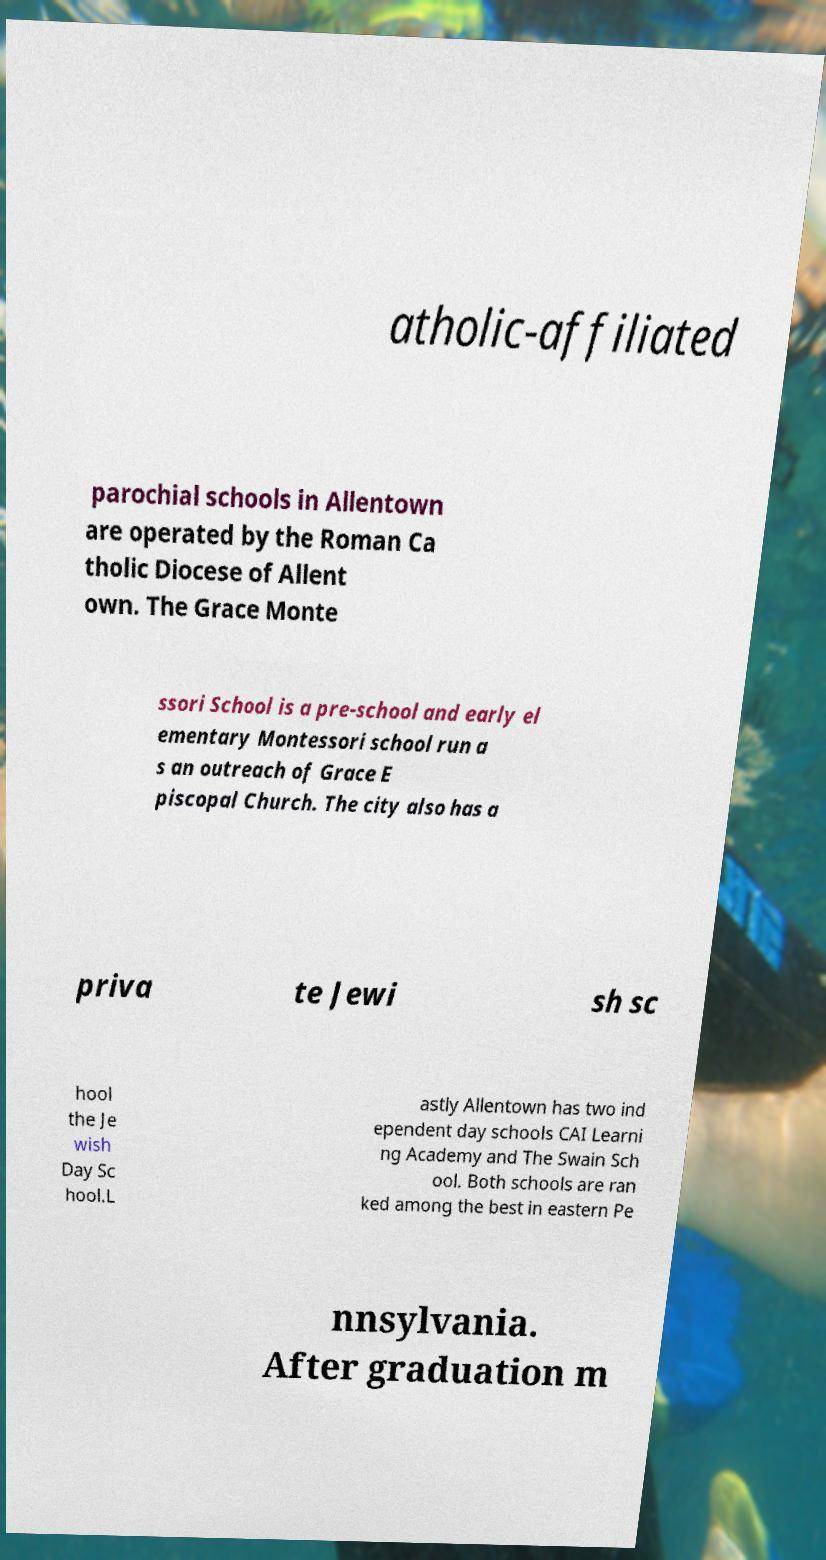Please identify and transcribe the text found in this image. atholic-affiliated parochial schools in Allentown are operated by the Roman Ca tholic Diocese of Allent own. The Grace Monte ssori School is a pre-school and early el ementary Montessori school run a s an outreach of Grace E piscopal Church. The city also has a priva te Jewi sh sc hool the Je wish Day Sc hool.L astly Allentown has two ind ependent day schools CAI Learni ng Academy and The Swain Sch ool. Both schools are ran ked among the best in eastern Pe nnsylvania. After graduation m 